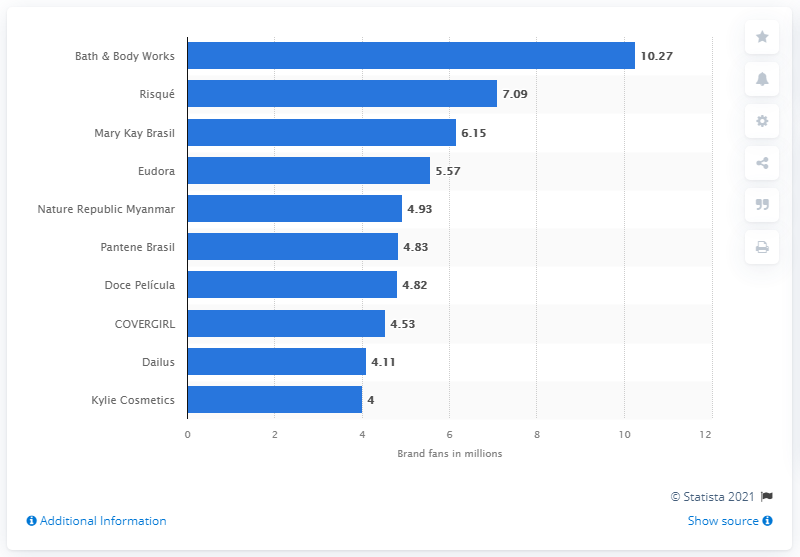List a handful of essential elements in this visual. Bath & Body Works had 10,270 followers on Facebook as of January 2021. In January 2021, Bath & Body Works was ranked as the most popular brand on Facebook. 